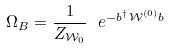Convert formula to latex. <formula><loc_0><loc_0><loc_500><loc_500>\Omega _ { B } = \frac { 1 } { Z _ { \mathcal { W } _ { 0 } } } \ e ^ { - b ^ { \dag } \mathcal { W } ^ { ( 0 ) } b }</formula> 